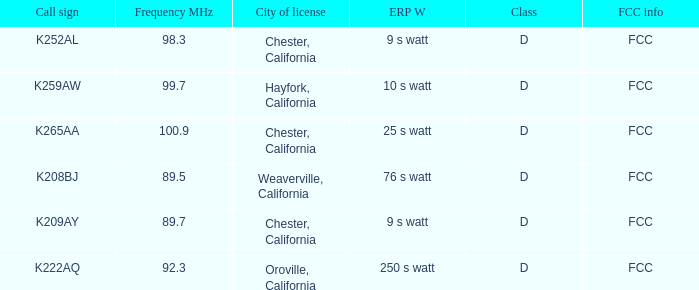Name the call sign with frequency of 89.5 K208BJ. 